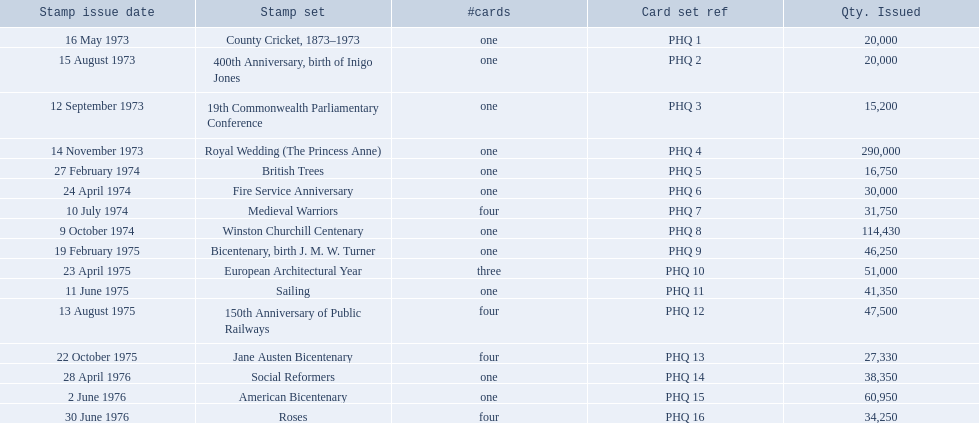Which stamp groupings featured three or more cards? Medieval Warriors, European Architectural Year, 150th Anniversary of Public Railways, Jane Austen Bicentenary, Roses. Out of these, which one solely comprises three cards? European Architectural Year. 